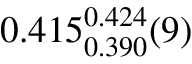<formula> <loc_0><loc_0><loc_500><loc_500>0 . 4 1 5 _ { 0 . 3 9 0 } ^ { 0 . 4 2 4 } ( 9 )</formula> 